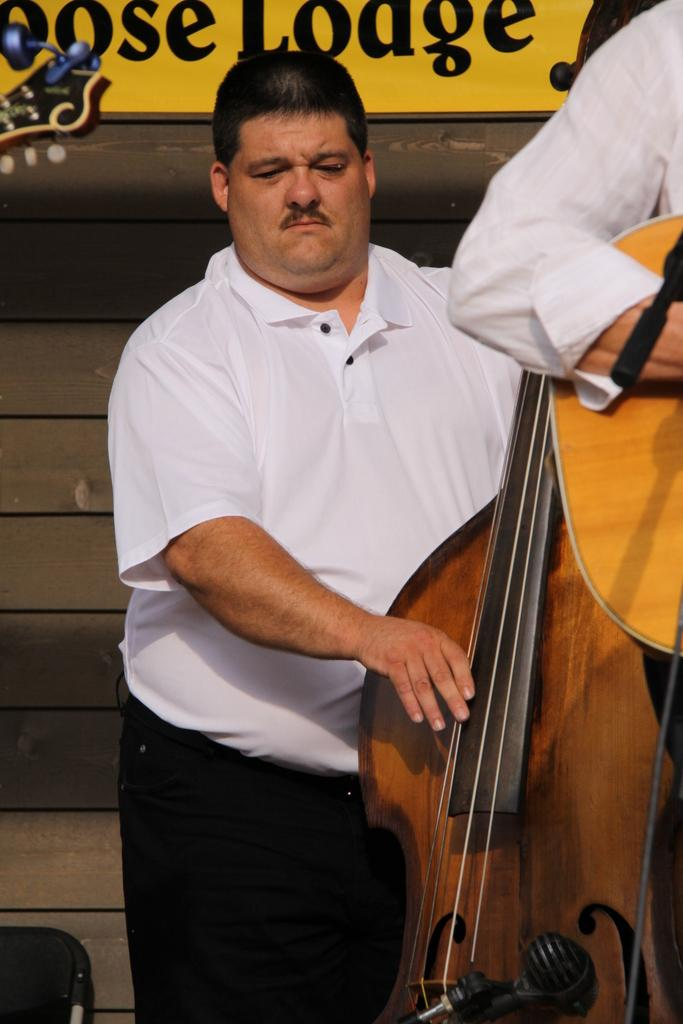How many people are present in the image? There are two persons standing in the image. What is one of the persons holding? One person is holding a music instrument. What can be seen in the background of the image? There is a brown color wall in the background of the image. What type of goat is present in the image? There is no goat present in the image. What answer is being given by the person holding the music instrument? The image does not show a situation where someone is giving an answer, so it cannot be determined from the image. 